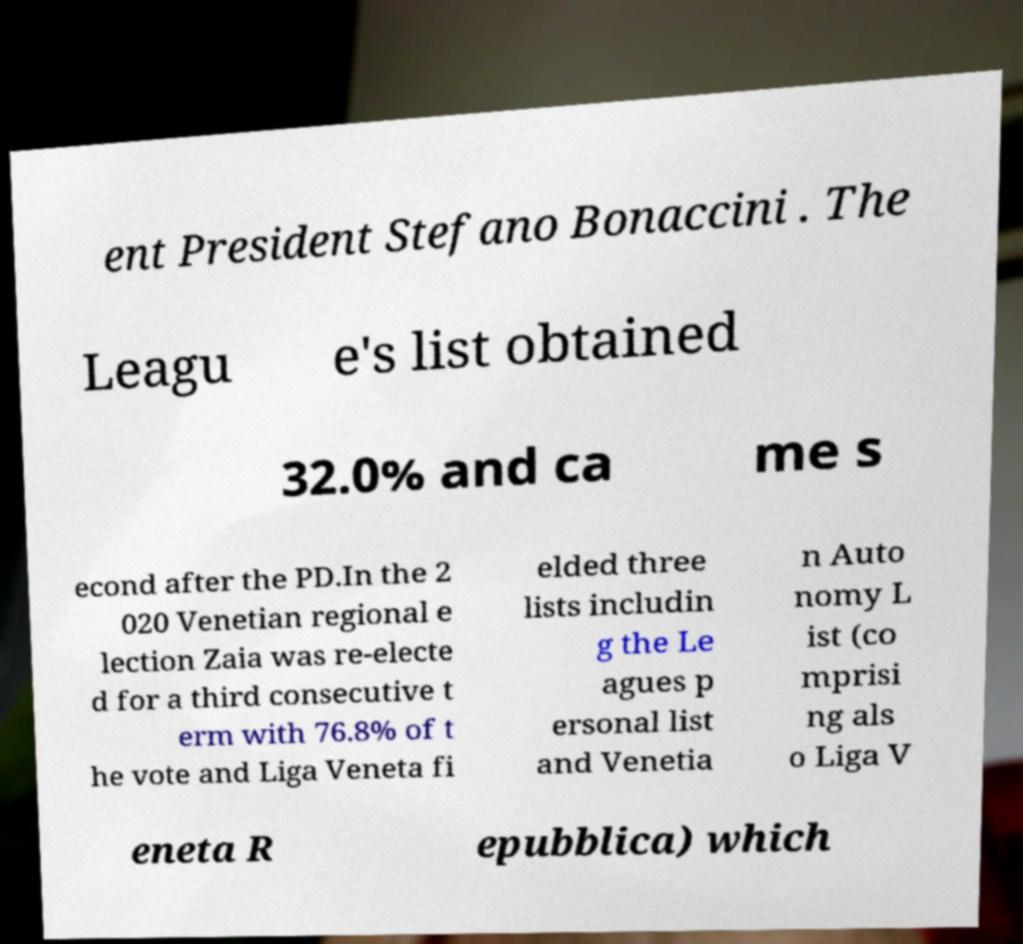Could you assist in decoding the text presented in this image and type it out clearly? ent President Stefano Bonaccini . The Leagu e's list obtained 32.0% and ca me s econd after the PD.In the 2 020 Venetian regional e lection Zaia was re-electe d for a third consecutive t erm with 76.8% of t he vote and Liga Veneta fi elded three lists includin g the Le agues p ersonal list and Venetia n Auto nomy L ist (co mprisi ng als o Liga V eneta R epubblica) which 